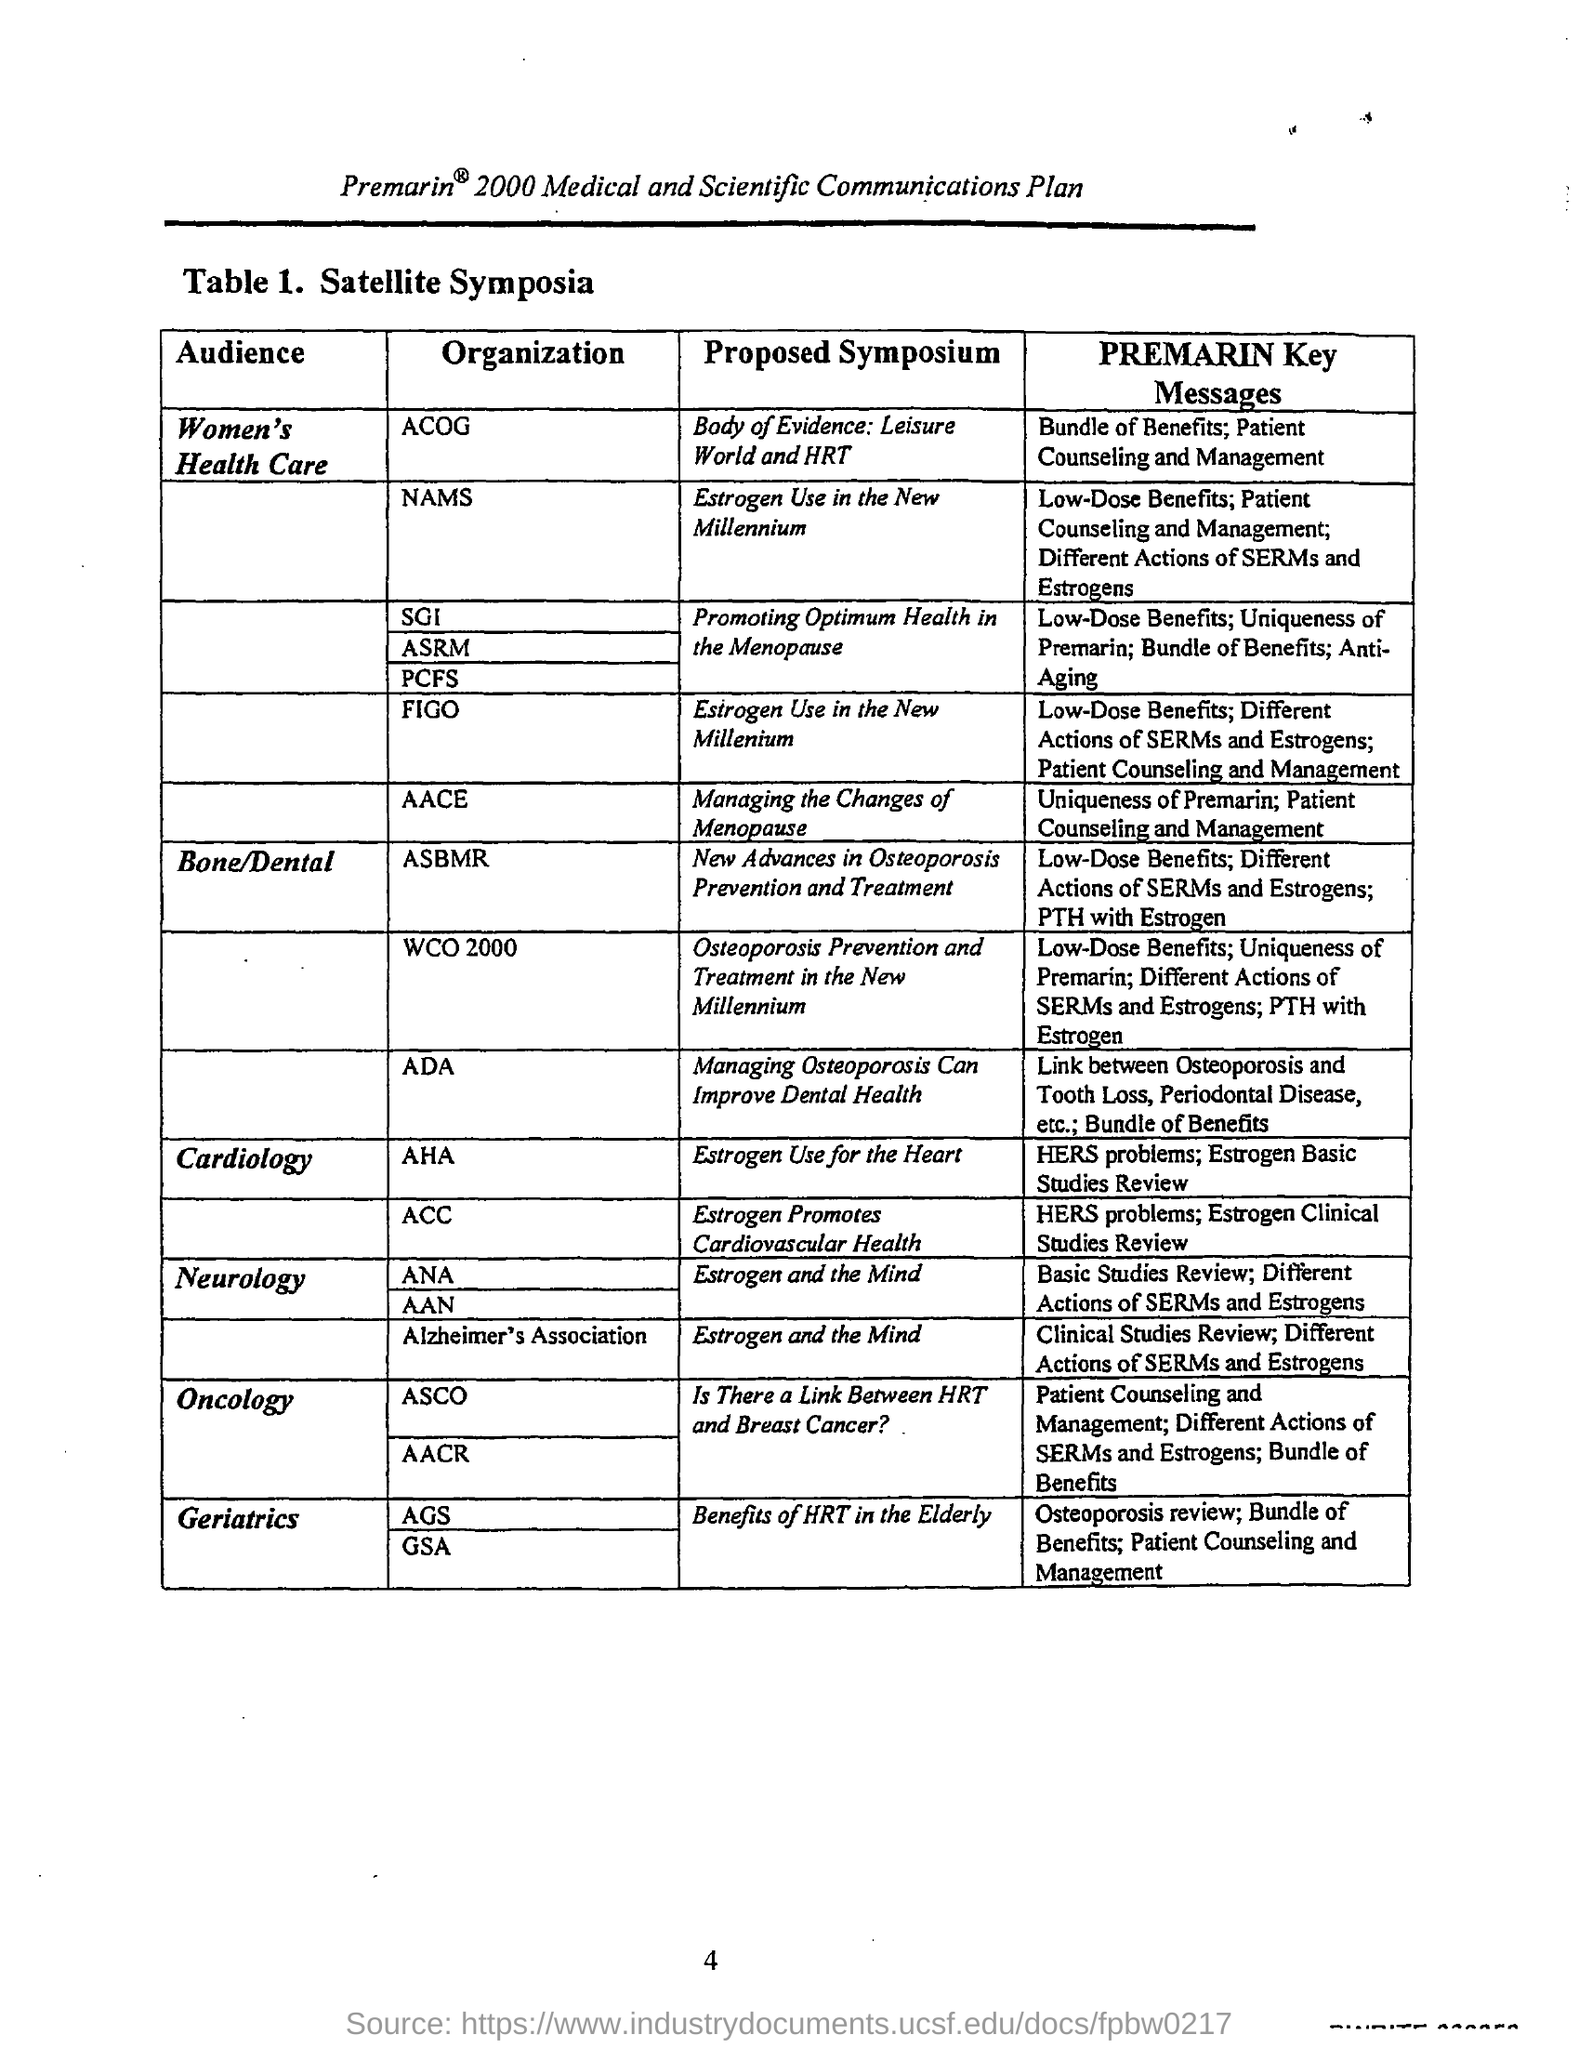Who is the audience of "Body of Evidence"?
Your answer should be very brief. Women's Health Care. What is Premarin Key messages of AACE?
Provide a short and direct response. Uniqueness of Premarin; Patient counselling and management. 